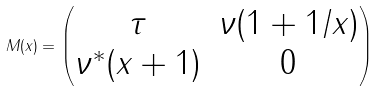<formula> <loc_0><loc_0><loc_500><loc_500>M ( x ) = \begin{pmatrix} \tau & \nu ( 1 + 1 / x ) \\ \nu ^ { * } ( x + 1 ) & 0 \end{pmatrix}</formula> 